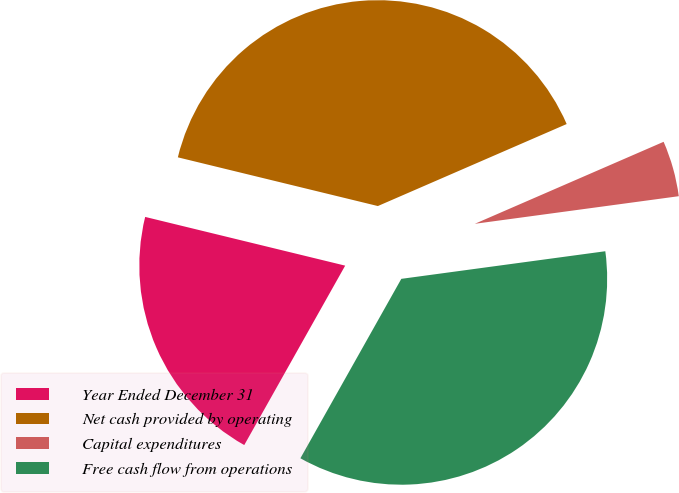<chart> <loc_0><loc_0><loc_500><loc_500><pie_chart><fcel>Year Ended December 31<fcel>Net cash provided by operating<fcel>Capital expenditures<fcel>Free cash flow from operations<nl><fcel>20.65%<fcel>39.68%<fcel>4.38%<fcel>35.3%<nl></chart> 